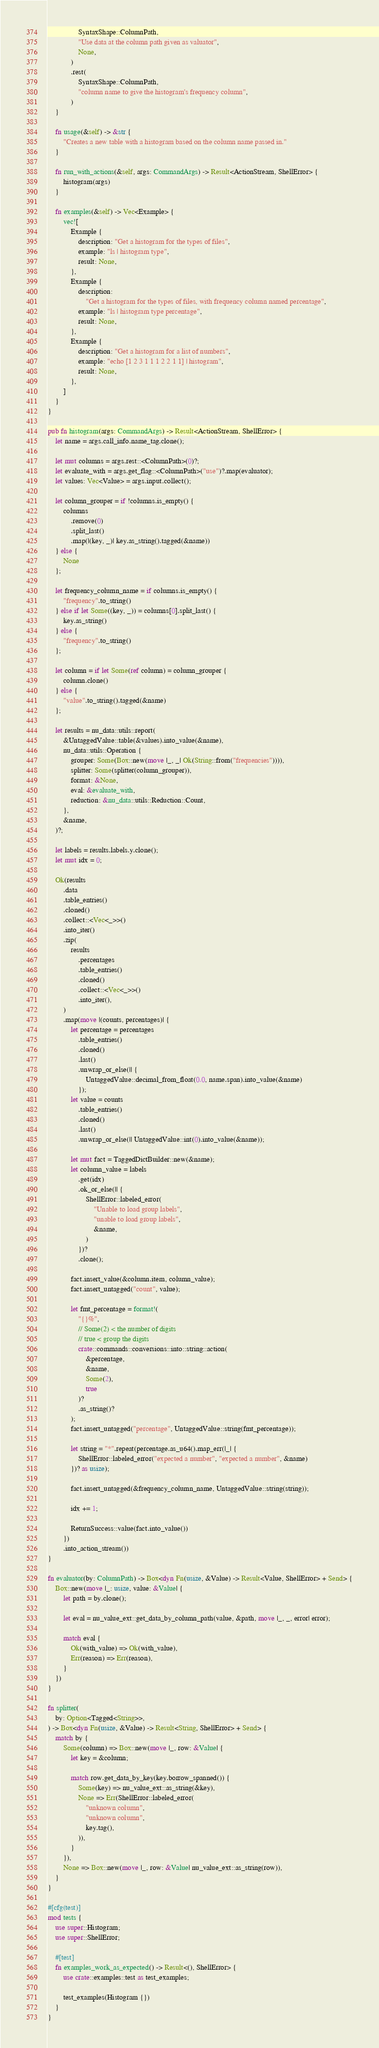Convert code to text. <code><loc_0><loc_0><loc_500><loc_500><_Rust_>                SyntaxShape::ColumnPath,
                "Use data at the column path given as valuator",
                None,
            )
            .rest(
                SyntaxShape::ColumnPath,
                "column name to give the histogram's frequency column",
            )
    }

    fn usage(&self) -> &str {
        "Creates a new table with a histogram based on the column name passed in."
    }

    fn run_with_actions(&self, args: CommandArgs) -> Result<ActionStream, ShellError> {
        histogram(args)
    }

    fn examples(&self) -> Vec<Example> {
        vec![
            Example {
                description: "Get a histogram for the types of files",
                example: "ls | histogram type",
                result: None,
            },
            Example {
                description:
                    "Get a histogram for the types of files, with frequency column named percentage",
                example: "ls | histogram type percentage",
                result: None,
            },
            Example {
                description: "Get a histogram for a list of numbers",
                example: "echo [1 2 3 1 1 1 2 2 1 1] | histogram",
                result: None,
            },
        ]
    }
}

pub fn histogram(args: CommandArgs) -> Result<ActionStream, ShellError> {
    let name = args.call_info.name_tag.clone();

    let mut columns = args.rest::<ColumnPath>(0)?;
    let evaluate_with = args.get_flag::<ColumnPath>("use")?.map(evaluator);
    let values: Vec<Value> = args.input.collect();

    let column_grouper = if !columns.is_empty() {
        columns
            .remove(0)
            .split_last()
            .map(|(key, _)| key.as_string().tagged(&name))
    } else {
        None
    };

    let frequency_column_name = if columns.is_empty() {
        "frequency".to_string()
    } else if let Some((key, _)) = columns[0].split_last() {
        key.as_string()
    } else {
        "frequency".to_string()
    };

    let column = if let Some(ref column) = column_grouper {
        column.clone()
    } else {
        "value".to_string().tagged(&name)
    };

    let results = nu_data::utils::report(
        &UntaggedValue::table(&values).into_value(&name),
        nu_data::utils::Operation {
            grouper: Some(Box::new(move |_, _| Ok(String::from("frequencies")))),
            splitter: Some(splitter(column_grouper)),
            format: &None,
            eval: &evaluate_with,
            reduction: &nu_data::utils::Reduction::Count,
        },
        &name,
    )?;

    let labels = results.labels.y.clone();
    let mut idx = 0;

    Ok(results
        .data
        .table_entries()
        .cloned()
        .collect::<Vec<_>>()
        .into_iter()
        .zip(
            results
                .percentages
                .table_entries()
                .cloned()
                .collect::<Vec<_>>()
                .into_iter(),
        )
        .map(move |(counts, percentages)| {
            let percentage = percentages
                .table_entries()
                .cloned()
                .last()
                .unwrap_or_else(|| {
                    UntaggedValue::decimal_from_float(0.0, name.span).into_value(&name)
                });
            let value = counts
                .table_entries()
                .cloned()
                .last()
                .unwrap_or_else(|| UntaggedValue::int(0).into_value(&name));

            let mut fact = TaggedDictBuilder::new(&name);
            let column_value = labels
                .get(idx)
                .ok_or_else(|| {
                    ShellError::labeled_error(
                        "Unable to load group labels",
                        "unable to load group labels",
                        &name,
                    )
                })?
                .clone();

            fact.insert_value(&column.item, column_value);
            fact.insert_untagged("count", value);

            let fmt_percentage = format!(
                "{}%",
                // Some(2) < the number of digits
                // true < group the digits
                crate::commands::conversions::into::string::action(
                    &percentage,
                    &name,
                    Some(2),
                    true
                )?
                .as_string()?
            );
            fact.insert_untagged("percentage", UntaggedValue::string(fmt_percentage));

            let string = "*".repeat(percentage.as_u64().map_err(|_| {
                ShellError::labeled_error("expected a number", "expected a number", &name)
            })? as usize);

            fact.insert_untagged(&frequency_column_name, UntaggedValue::string(string));

            idx += 1;

            ReturnSuccess::value(fact.into_value())
        })
        .into_action_stream())
}

fn evaluator(by: ColumnPath) -> Box<dyn Fn(usize, &Value) -> Result<Value, ShellError> + Send> {
    Box::new(move |_: usize, value: &Value| {
        let path = by.clone();

        let eval = nu_value_ext::get_data_by_column_path(value, &path, move |_, _, error| error);

        match eval {
            Ok(with_value) => Ok(with_value),
            Err(reason) => Err(reason),
        }
    })
}

fn splitter(
    by: Option<Tagged<String>>,
) -> Box<dyn Fn(usize, &Value) -> Result<String, ShellError> + Send> {
    match by {
        Some(column) => Box::new(move |_, row: &Value| {
            let key = &column;

            match row.get_data_by_key(key.borrow_spanned()) {
                Some(key) => nu_value_ext::as_string(&key),
                None => Err(ShellError::labeled_error(
                    "unknown column",
                    "unknown column",
                    key.tag(),
                )),
            }
        }),
        None => Box::new(move |_, row: &Value| nu_value_ext::as_string(row)),
    }
}

#[cfg(test)]
mod tests {
    use super::Histogram;
    use super::ShellError;

    #[test]
    fn examples_work_as_expected() -> Result<(), ShellError> {
        use crate::examples::test as test_examples;

        test_examples(Histogram {})
    }
}
</code> 